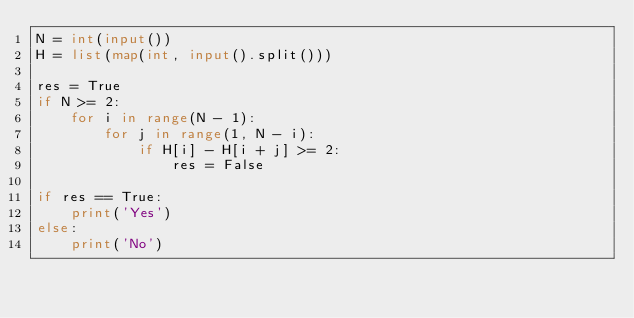Convert code to text. <code><loc_0><loc_0><loc_500><loc_500><_Python_>N = int(input())
H = list(map(int, input().split()))

res = True
if N >= 2:
    for i in range(N - 1):
        for j in range(1, N - i):
            if H[i] - H[i + j] >= 2:
                res = False

if res == True:
    print('Yes')
else:
    print('No')</code> 